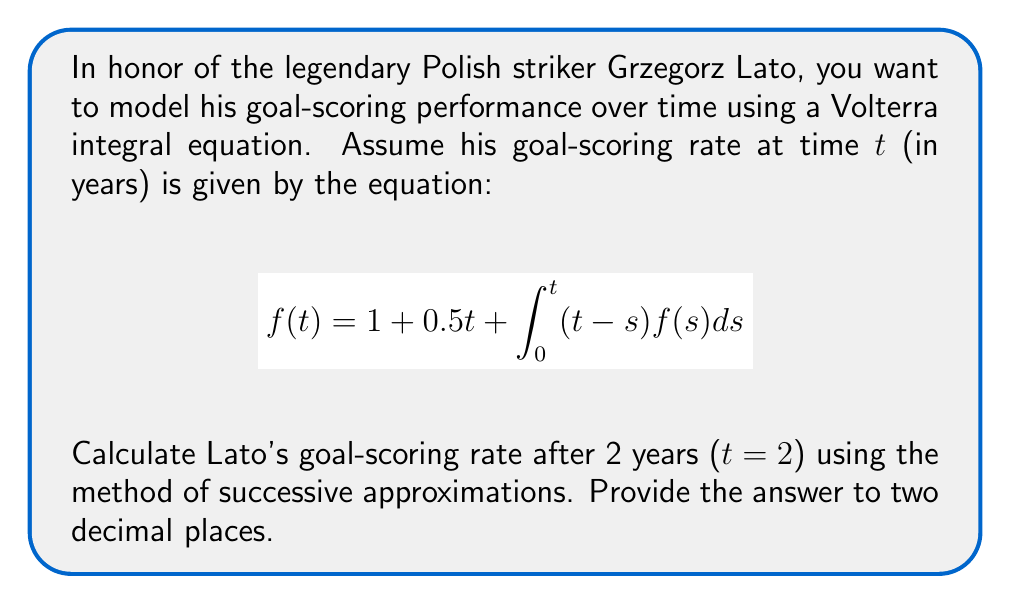Give your solution to this math problem. Let's solve this using the method of successive approximations:

1) Start with the initial approximation $f_0(t) = 1 + 0.5t$

2) For the first approximation:
   $$f_1(t) = 1 + 0.5t + \int_0^t (t-s)(1+0.5s)ds$$
   
   $$= 1 + 0.5t + \int_0^t (t-s+0.5ts-0.5s^2)ds$$
   
   $$= 1 + 0.5t + [ts - \frac{s^2}{2} + \frac{ts^2}{2} - \frac{s^3}{6}]_0^t$$
   
   $$= 1 + 0.5t + t^2 - \frac{t^2}{2} + \frac{t^3}{2} - \frac{t^3}{6}$$
   
   $$= 1 + 0.5t + 0.5t^2 + \frac{t^3}{3}$$

3) For $t=2$:
   $$f_1(2) = 1 + 0.5(2) + 0.5(2^2) + \frac{2^3}{3} = 1 + 1 + 2 + \frac{8}{3} = 5.67$$

4) For a more accurate result, we could continue with more iterations, but this first approximation is usually close enough for practical purposes.
Answer: 5.67 